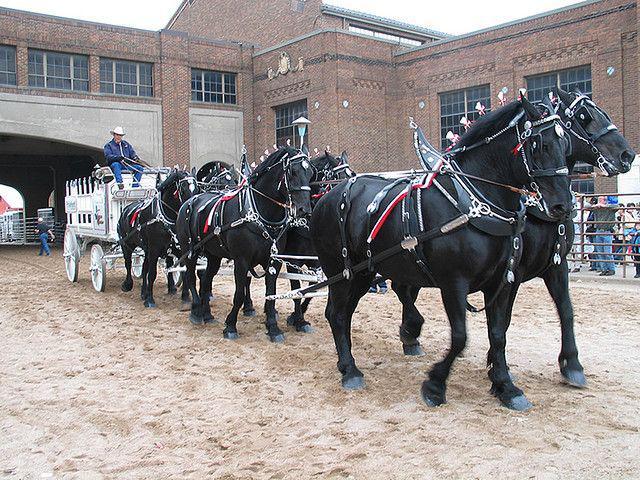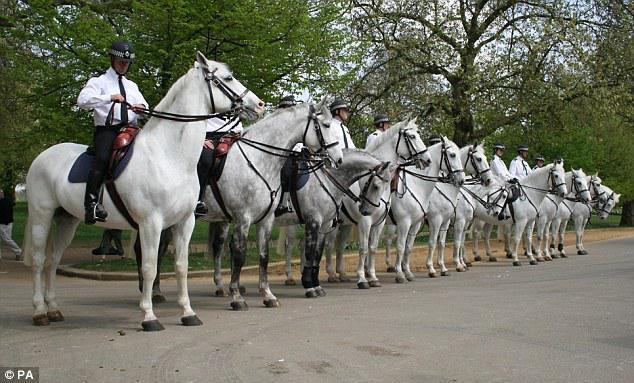The first image is the image on the left, the second image is the image on the right. Assess this claim about the two images: "There are more than five white horses in one of the images.". Correct or not? Answer yes or no. Yes. 